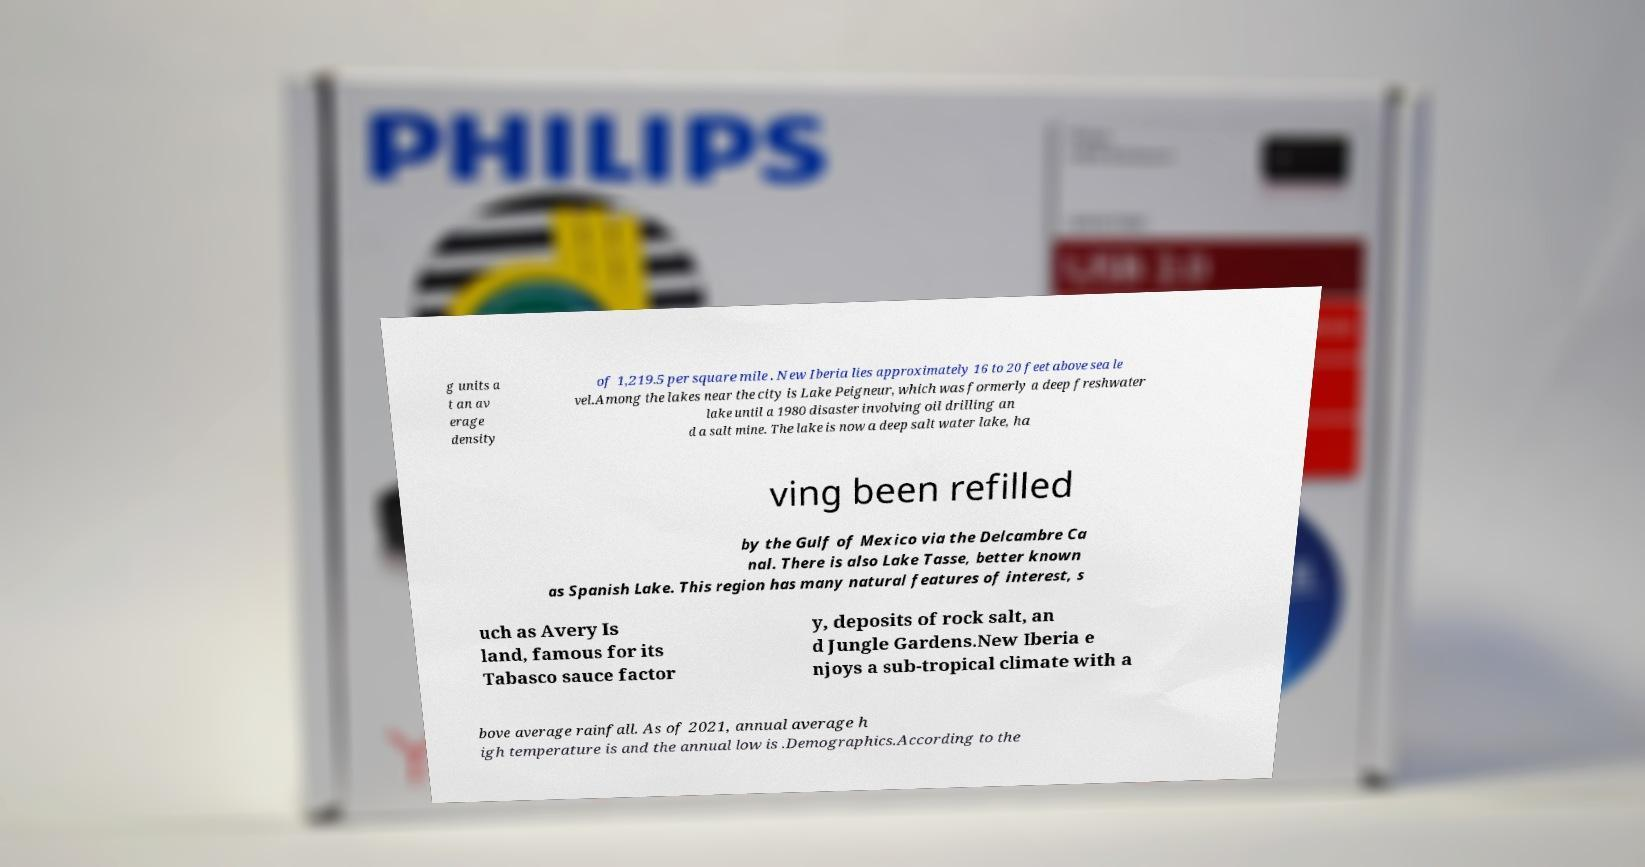Can you accurately transcribe the text from the provided image for me? g units a t an av erage density of 1,219.5 per square mile . New Iberia lies approximately 16 to 20 feet above sea le vel.Among the lakes near the city is Lake Peigneur, which was formerly a deep freshwater lake until a 1980 disaster involving oil drilling an d a salt mine. The lake is now a deep salt water lake, ha ving been refilled by the Gulf of Mexico via the Delcambre Ca nal. There is also Lake Tasse, better known as Spanish Lake. This region has many natural features of interest, s uch as Avery Is land, famous for its Tabasco sauce factor y, deposits of rock salt, an d Jungle Gardens.New Iberia e njoys a sub-tropical climate with a bove average rainfall. As of 2021, annual average h igh temperature is and the annual low is .Demographics.According to the 